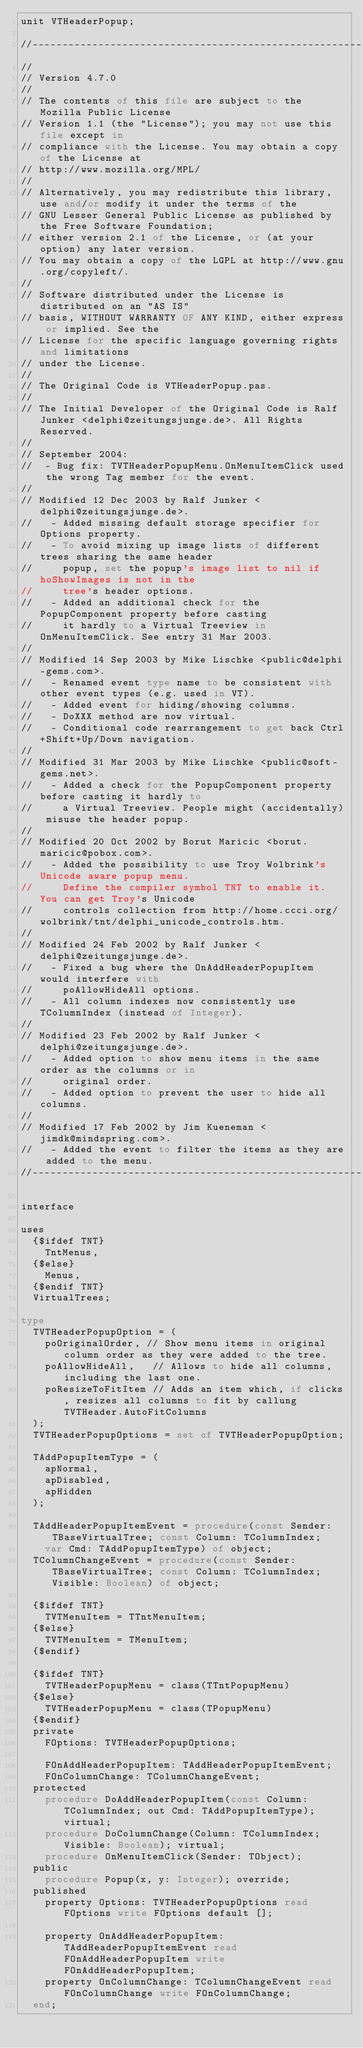<code> <loc_0><loc_0><loc_500><loc_500><_Pascal_>unit VTHeaderPopup;

//----------------------------------------------------------------------------------------------------------------------
//
// Version 4.7.0
//
// The contents of this file are subject to the Mozilla Public License
// Version 1.1 (the "License"); you may not use this file except in
// compliance with the License. You may obtain a copy of the License at
// http://www.mozilla.org/MPL/
//
// Alternatively, you may redistribute this library, use and/or modify it under the terms of the
// GNU Lesser General Public License as published by the Free Software Foundation;
// either version 2.1 of the License, or (at your option) any later version.
// You may obtain a copy of the LGPL at http://www.gnu.org/copyleft/.
//
// Software distributed under the License is distributed on an "AS IS"
// basis, WITHOUT WARRANTY OF ANY KIND, either express or implied. See the
// License for the specific language governing rights and limitations
// under the License.
//
// The Original Code is VTHeaderPopup.pas.
//
// The Initial Developer of the Original Code is Ralf Junker <delphi@zeitungsjunge.de>. All Rights Reserved.
//
// September 2004:
//  - Bug fix: TVTHeaderPopupMenu.OnMenuItemClick used the wrong Tag member for the event.
// 
// Modified 12 Dec 2003 by Ralf Junker <delphi@zeitungsjunge.de>.
//   - Added missing default storage specifier for Options property.
//   - To avoid mixing up image lists of different trees sharing the same header 
//     popup, set the popup's image list to nil if hoShowImages is not in the 
//     tree's header options.
//   - Added an additional check for the PopupComponent property before casting 
//     it hardly to a Virtual Treeview in OnMenuItemClick. See entry 31 Mar 2003.
//
// Modified 14 Sep 2003 by Mike Lischke <public@delphi-gems.com>.
//   - Renamed event type name to be consistent with other event types (e.g. used in VT).
//   - Added event for hiding/showing columns.
//   - DoXXX method are now virtual.
//   - Conditional code rearrangement to get back Ctrl+Shift+Up/Down navigation.
//
// Modified 31 Mar 2003 by Mike Lischke <public@soft-gems.net>.
//   - Added a check for the PopupComponent property before casting it hardly to 
//     a Virtual Treeview. People might (accidentally) misuse the header popup.
//
// Modified 20 Oct 2002 by Borut Maricic <borut.maricic@pobox.com>.
//   - Added the possibility to use Troy Wolbrink's Unicode aware popup menu. 
//     Define the compiler symbol TNT to enable it. You can get Troy's Unicode
//     controls collection from http://home.ccci.org/wolbrink/tnt/delphi_unicode_controls.htm.
//
// Modified 24 Feb 2002 by Ralf Junker <delphi@zeitungsjunge.de>.
//   - Fixed a bug where the OnAddHeaderPopupItem would interfere with 
//     poAllowHideAll options.
//   - All column indexes now consistently use TColumnIndex (instead of Integer).
//
// Modified 23 Feb 2002 by Ralf Junker <delphi@zeitungsjunge.de>.
//   - Added option to show menu items in the same order as the columns or in 
//     original order.
//   - Added option to prevent the user to hide all columns.
//
// Modified 17 Feb 2002 by Jim Kueneman <jimdk@mindspring.com>.
//   - Added the event to filter the items as they are added to the menu.
//----------------------------------------------------------------------------------------------------------------------

interface

uses
  {$ifdef TNT}
    TntMenus,
  {$else}
    Menus,
  {$endif TNT}
  VirtualTrees;

type
  TVTHeaderPopupOption = (
    poOriginalOrder, // Show menu items in original column order as they were added to the tree.
    poAllowHideAll,   // Allows to hide all columns, including the last one.
    poResizeToFitItem // Adds an item which, if clicks, resizes all columns to fit by callung TVTHeader.AutoFitColumns
  );
  TVTHeaderPopupOptions = set of TVTHeaderPopupOption;

  TAddPopupItemType = (
    apNormal,
    apDisabled,
    apHidden
  );

  TAddHeaderPopupItemEvent = procedure(const Sender: TBaseVirtualTree; const Column: TColumnIndex;
    var Cmd: TAddPopupItemType) of object;
  TColumnChangeEvent = procedure(const Sender: TBaseVirtualTree; const Column: TColumnIndex; Visible: Boolean) of object;

  {$ifdef TNT}
    TVTMenuItem = TTntMenuItem;
  {$else}
    TVTMenuItem = TMenuItem;
  {$endif}

  {$ifdef TNT}
    TVTHeaderPopupMenu = class(TTntPopupMenu)
  {$else}
    TVTHeaderPopupMenu = class(TPopupMenu)
  {$endif}
  private
    FOptions: TVTHeaderPopupOptions;

    FOnAddHeaderPopupItem: TAddHeaderPopupItemEvent;
    FOnColumnChange: TColumnChangeEvent;
  protected
    procedure DoAddHeaderPopupItem(const Column: TColumnIndex; out Cmd: TAddPopupItemType); virtual;
    procedure DoColumnChange(Column: TColumnIndex; Visible: Boolean); virtual;
    procedure OnMenuItemClick(Sender: TObject);
  public
    procedure Popup(x, y: Integer); override;
  published
    property Options: TVTHeaderPopupOptions read FOptions write FOptions default [];

    property OnAddHeaderPopupItem: TAddHeaderPopupItemEvent read FOnAddHeaderPopupItem write FOnAddHeaderPopupItem;
    property OnColumnChange: TColumnChangeEvent read FOnColumnChange write FOnColumnChange;
  end;
</code> 